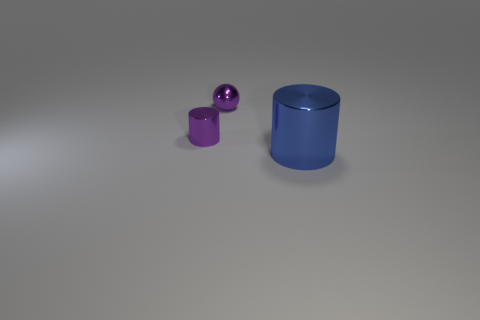Subtract all blue cylinders. How many cylinders are left? 1 Add 2 tiny cylinders. How many objects exist? 5 Subtract all cylinders. How many objects are left? 1 Subtract 1 balls. How many balls are left? 0 Subtract all brown cubes. How many gray spheres are left? 0 Subtract all tiny gray rubber blocks. Subtract all large blue metallic objects. How many objects are left? 2 Add 1 shiny balls. How many shiny balls are left? 2 Add 1 blue cylinders. How many blue cylinders exist? 2 Subtract 0 brown cubes. How many objects are left? 3 Subtract all brown cylinders. Subtract all yellow cubes. How many cylinders are left? 2 